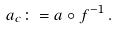Convert formula to latex. <formula><loc_0><loc_0><loc_500><loc_500>a _ { c } \colon = a \circ f ^ { - 1 } \, .</formula> 